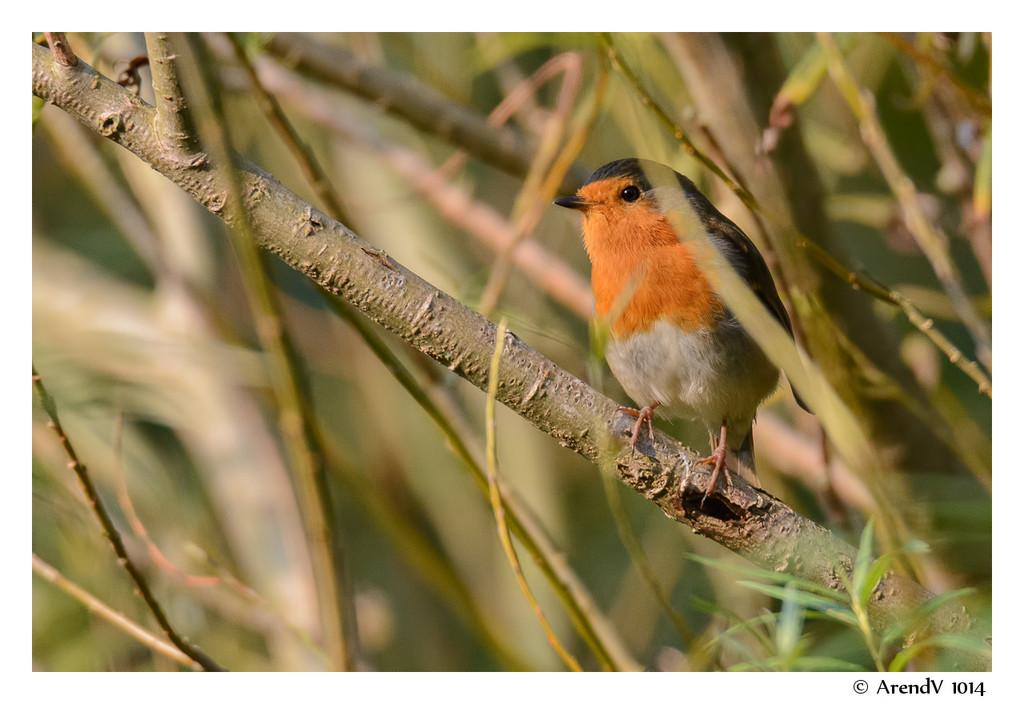What is the main subject in the foreground of the image? There is a bird in the foreground of the image. Where is the bird located? The bird is on a branch. What can be seen in the background of the image? There are branches of plants in the background of the image. What type of bed can be seen in the image? There is no bed present in the image; it features a bird on a branch with branches of plants in the background. 